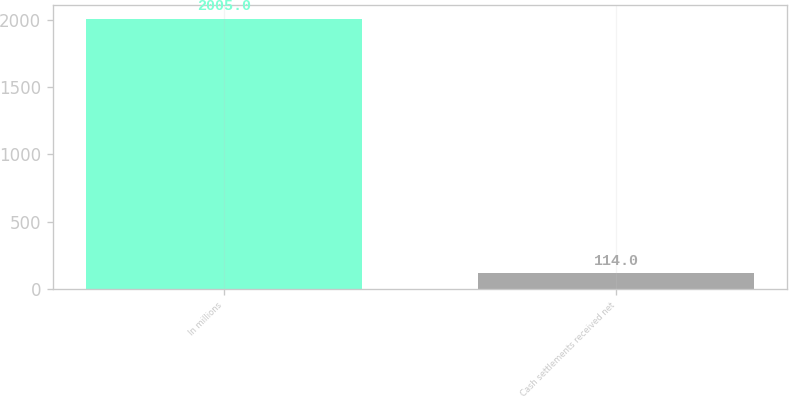Convert chart. <chart><loc_0><loc_0><loc_500><loc_500><bar_chart><fcel>In millions<fcel>Cash settlements received net<nl><fcel>2005<fcel>114<nl></chart> 